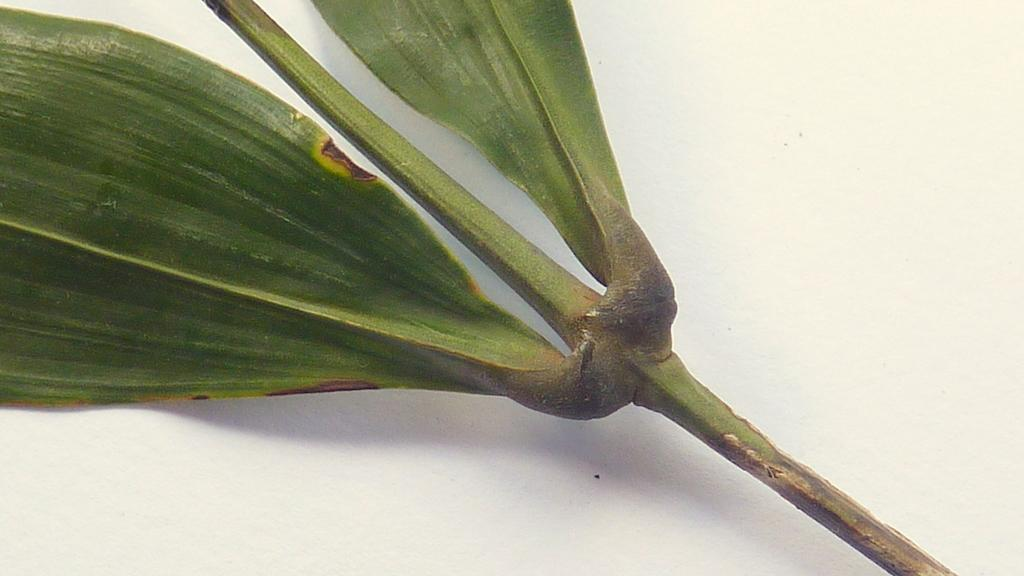What type of plant material is present in the image? There are leaves in the image. How are the leaves arranged in the image? The leaves are on a stem. On what surface are the leaves and stem placed? The leaves and stem are placed on a surface. What type of flock can be seen flying in the image? There is no flock present in the image; it only features leaves on a stem. 